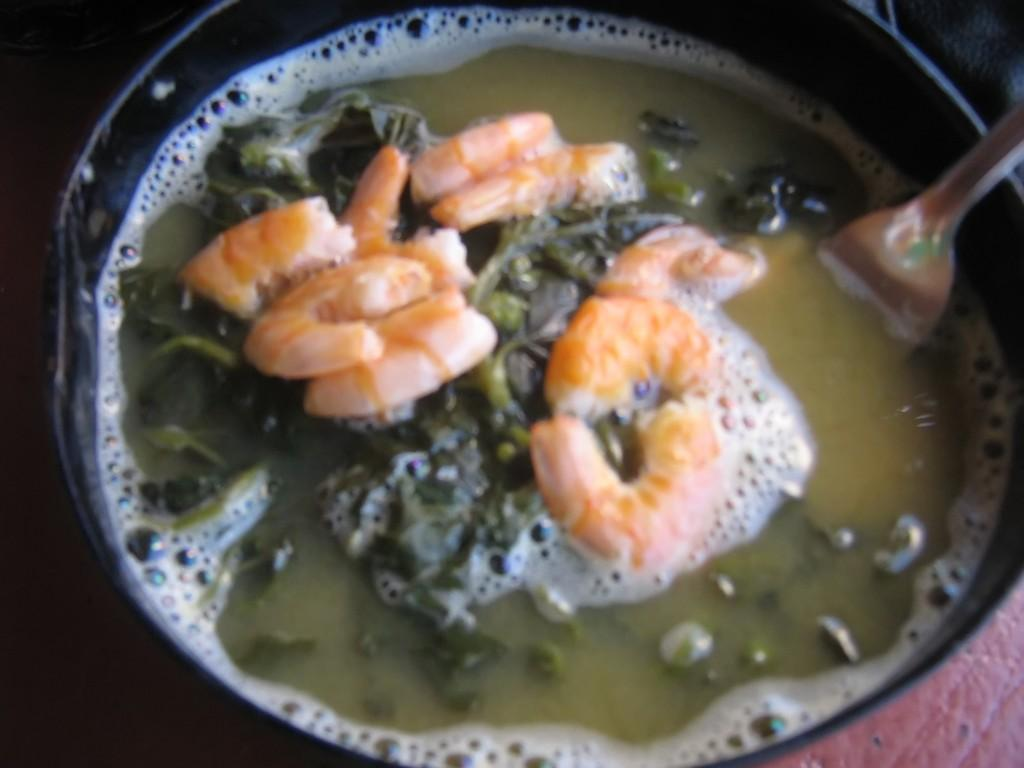What is the main object in the center of the image? There is a pan in the center of the image. What is inside the pan? There is a spoon and food items in the pan. Can you describe the contents of the pan? The pan contains food items, but the specific type of food cannot be determined from the image. What type of letters can be seen floating in the ocean in the image? There is no ocean or letters present in the image; it features a pan with a spoon and food items. 